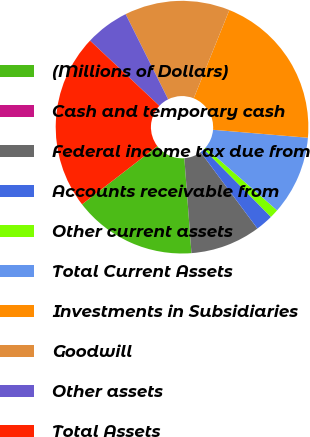Convert chart to OTSL. <chart><loc_0><loc_0><loc_500><loc_500><pie_chart><fcel>(Millions of Dollars)<fcel>Cash and temporary cash<fcel>Federal income tax due from<fcel>Accounts receivable from<fcel>Other current assets<fcel>Total Current Assets<fcel>Investments in Subsidiaries<fcel>Goodwill<fcel>Other assets<fcel>Total Assets<nl><fcel>15.73%<fcel>0.0%<fcel>8.99%<fcel>2.25%<fcel>1.13%<fcel>10.11%<fcel>20.22%<fcel>13.48%<fcel>5.62%<fcel>22.47%<nl></chart> 